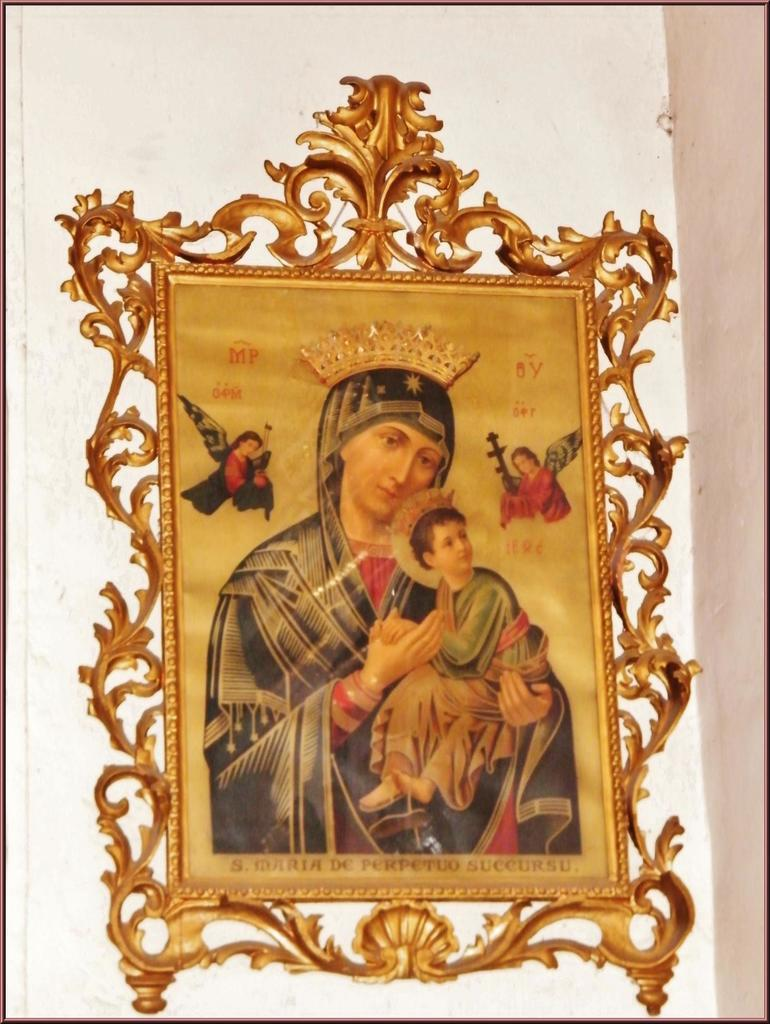What is the main subject of the image? There is a portrait in the image. Where is the portrait located? The portrait is present on a wall. How many balls are visible in the portrait? There are no balls visible in the portrait or the image; it only features a portrait on a wall. 